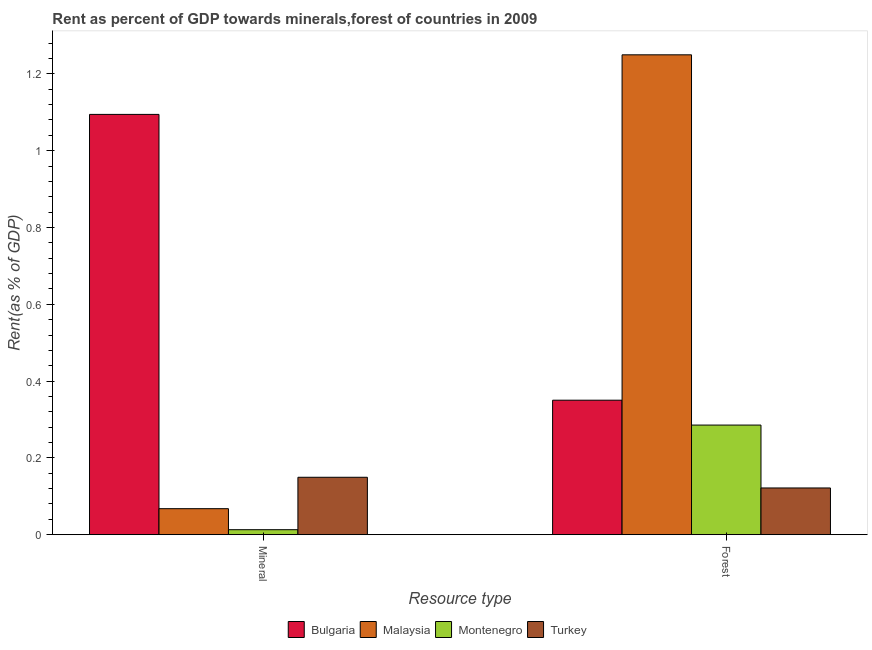How many different coloured bars are there?
Provide a succinct answer. 4. How many groups of bars are there?
Your answer should be very brief. 2. Are the number of bars per tick equal to the number of legend labels?
Your answer should be compact. Yes. Are the number of bars on each tick of the X-axis equal?
Offer a very short reply. Yes. How many bars are there on the 1st tick from the left?
Your response must be concise. 4. How many bars are there on the 2nd tick from the right?
Your answer should be compact. 4. What is the label of the 2nd group of bars from the left?
Ensure brevity in your answer.  Forest. What is the mineral rent in Montenegro?
Give a very brief answer. 0.01. Across all countries, what is the maximum forest rent?
Your answer should be very brief. 1.25. Across all countries, what is the minimum mineral rent?
Provide a succinct answer. 0.01. In which country was the mineral rent maximum?
Make the answer very short. Bulgaria. In which country was the mineral rent minimum?
Ensure brevity in your answer.  Montenegro. What is the total forest rent in the graph?
Keep it short and to the point. 2.01. What is the difference between the mineral rent in Bulgaria and that in Turkey?
Provide a short and direct response. 0.95. What is the difference between the mineral rent in Montenegro and the forest rent in Malaysia?
Provide a succinct answer. -1.24. What is the average forest rent per country?
Your response must be concise. 0.5. What is the difference between the forest rent and mineral rent in Bulgaria?
Make the answer very short. -0.74. In how many countries, is the mineral rent greater than 0.6400000000000001 %?
Keep it short and to the point. 1. What is the ratio of the mineral rent in Malaysia to that in Montenegro?
Provide a short and direct response. 5.21. Is the forest rent in Bulgaria less than that in Turkey?
Your answer should be very brief. No. In how many countries, is the mineral rent greater than the average mineral rent taken over all countries?
Provide a short and direct response. 1. What does the 4th bar from the left in Forest represents?
Your answer should be compact. Turkey. What does the 3rd bar from the right in Forest represents?
Your answer should be very brief. Malaysia. How many bars are there?
Provide a short and direct response. 8. Are all the bars in the graph horizontal?
Your response must be concise. No. How many countries are there in the graph?
Your answer should be compact. 4. What is the difference between two consecutive major ticks on the Y-axis?
Keep it short and to the point. 0.2. Does the graph contain grids?
Provide a short and direct response. No. How many legend labels are there?
Offer a terse response. 4. What is the title of the graph?
Offer a very short reply. Rent as percent of GDP towards minerals,forest of countries in 2009. What is the label or title of the X-axis?
Offer a terse response. Resource type. What is the label or title of the Y-axis?
Your answer should be very brief. Rent(as % of GDP). What is the Rent(as % of GDP) of Bulgaria in Mineral?
Your answer should be compact. 1.09. What is the Rent(as % of GDP) of Malaysia in Mineral?
Offer a terse response. 0.07. What is the Rent(as % of GDP) of Montenegro in Mineral?
Keep it short and to the point. 0.01. What is the Rent(as % of GDP) in Turkey in Mineral?
Ensure brevity in your answer.  0.15. What is the Rent(as % of GDP) of Bulgaria in Forest?
Make the answer very short. 0.35. What is the Rent(as % of GDP) in Malaysia in Forest?
Give a very brief answer. 1.25. What is the Rent(as % of GDP) of Montenegro in Forest?
Keep it short and to the point. 0.29. What is the Rent(as % of GDP) of Turkey in Forest?
Your answer should be very brief. 0.12. Across all Resource type, what is the maximum Rent(as % of GDP) of Bulgaria?
Provide a succinct answer. 1.09. Across all Resource type, what is the maximum Rent(as % of GDP) in Malaysia?
Ensure brevity in your answer.  1.25. Across all Resource type, what is the maximum Rent(as % of GDP) in Montenegro?
Your answer should be very brief. 0.29. Across all Resource type, what is the maximum Rent(as % of GDP) of Turkey?
Give a very brief answer. 0.15. Across all Resource type, what is the minimum Rent(as % of GDP) in Bulgaria?
Provide a succinct answer. 0.35. Across all Resource type, what is the minimum Rent(as % of GDP) of Malaysia?
Offer a very short reply. 0.07. Across all Resource type, what is the minimum Rent(as % of GDP) of Montenegro?
Your answer should be very brief. 0.01. Across all Resource type, what is the minimum Rent(as % of GDP) in Turkey?
Your answer should be compact. 0.12. What is the total Rent(as % of GDP) of Bulgaria in the graph?
Give a very brief answer. 1.44. What is the total Rent(as % of GDP) of Malaysia in the graph?
Your answer should be compact. 1.32. What is the total Rent(as % of GDP) of Montenegro in the graph?
Your answer should be very brief. 0.3. What is the total Rent(as % of GDP) in Turkey in the graph?
Ensure brevity in your answer.  0.27. What is the difference between the Rent(as % of GDP) in Bulgaria in Mineral and that in Forest?
Ensure brevity in your answer.  0.74. What is the difference between the Rent(as % of GDP) of Malaysia in Mineral and that in Forest?
Ensure brevity in your answer.  -1.18. What is the difference between the Rent(as % of GDP) of Montenegro in Mineral and that in Forest?
Provide a short and direct response. -0.27. What is the difference between the Rent(as % of GDP) of Turkey in Mineral and that in Forest?
Keep it short and to the point. 0.03. What is the difference between the Rent(as % of GDP) in Bulgaria in Mineral and the Rent(as % of GDP) in Malaysia in Forest?
Provide a succinct answer. -0.16. What is the difference between the Rent(as % of GDP) of Bulgaria in Mineral and the Rent(as % of GDP) of Montenegro in Forest?
Provide a short and direct response. 0.81. What is the difference between the Rent(as % of GDP) in Bulgaria in Mineral and the Rent(as % of GDP) in Turkey in Forest?
Give a very brief answer. 0.97. What is the difference between the Rent(as % of GDP) in Malaysia in Mineral and the Rent(as % of GDP) in Montenegro in Forest?
Ensure brevity in your answer.  -0.22. What is the difference between the Rent(as % of GDP) in Malaysia in Mineral and the Rent(as % of GDP) in Turkey in Forest?
Keep it short and to the point. -0.05. What is the difference between the Rent(as % of GDP) of Montenegro in Mineral and the Rent(as % of GDP) of Turkey in Forest?
Your response must be concise. -0.11. What is the average Rent(as % of GDP) in Bulgaria per Resource type?
Offer a very short reply. 0.72. What is the average Rent(as % of GDP) in Malaysia per Resource type?
Your response must be concise. 0.66. What is the average Rent(as % of GDP) of Montenegro per Resource type?
Your response must be concise. 0.15. What is the average Rent(as % of GDP) in Turkey per Resource type?
Ensure brevity in your answer.  0.14. What is the difference between the Rent(as % of GDP) in Bulgaria and Rent(as % of GDP) in Malaysia in Mineral?
Your answer should be very brief. 1.03. What is the difference between the Rent(as % of GDP) in Bulgaria and Rent(as % of GDP) in Montenegro in Mineral?
Keep it short and to the point. 1.08. What is the difference between the Rent(as % of GDP) in Bulgaria and Rent(as % of GDP) in Turkey in Mineral?
Make the answer very short. 0.94. What is the difference between the Rent(as % of GDP) of Malaysia and Rent(as % of GDP) of Montenegro in Mineral?
Provide a short and direct response. 0.05. What is the difference between the Rent(as % of GDP) in Malaysia and Rent(as % of GDP) in Turkey in Mineral?
Offer a very short reply. -0.08. What is the difference between the Rent(as % of GDP) in Montenegro and Rent(as % of GDP) in Turkey in Mineral?
Keep it short and to the point. -0.14. What is the difference between the Rent(as % of GDP) in Bulgaria and Rent(as % of GDP) in Malaysia in Forest?
Your response must be concise. -0.9. What is the difference between the Rent(as % of GDP) in Bulgaria and Rent(as % of GDP) in Montenegro in Forest?
Provide a succinct answer. 0.06. What is the difference between the Rent(as % of GDP) in Bulgaria and Rent(as % of GDP) in Turkey in Forest?
Your answer should be compact. 0.23. What is the difference between the Rent(as % of GDP) in Malaysia and Rent(as % of GDP) in Montenegro in Forest?
Your response must be concise. 0.96. What is the difference between the Rent(as % of GDP) of Malaysia and Rent(as % of GDP) of Turkey in Forest?
Your answer should be compact. 1.13. What is the difference between the Rent(as % of GDP) in Montenegro and Rent(as % of GDP) in Turkey in Forest?
Make the answer very short. 0.16. What is the ratio of the Rent(as % of GDP) of Bulgaria in Mineral to that in Forest?
Provide a succinct answer. 3.12. What is the ratio of the Rent(as % of GDP) of Malaysia in Mineral to that in Forest?
Provide a succinct answer. 0.05. What is the ratio of the Rent(as % of GDP) of Montenegro in Mineral to that in Forest?
Your answer should be compact. 0.05. What is the ratio of the Rent(as % of GDP) of Turkey in Mineral to that in Forest?
Keep it short and to the point. 1.23. What is the difference between the highest and the second highest Rent(as % of GDP) in Bulgaria?
Your response must be concise. 0.74. What is the difference between the highest and the second highest Rent(as % of GDP) of Malaysia?
Offer a very short reply. 1.18. What is the difference between the highest and the second highest Rent(as % of GDP) of Montenegro?
Provide a short and direct response. 0.27. What is the difference between the highest and the second highest Rent(as % of GDP) of Turkey?
Offer a very short reply. 0.03. What is the difference between the highest and the lowest Rent(as % of GDP) of Bulgaria?
Your response must be concise. 0.74. What is the difference between the highest and the lowest Rent(as % of GDP) of Malaysia?
Offer a terse response. 1.18. What is the difference between the highest and the lowest Rent(as % of GDP) in Montenegro?
Give a very brief answer. 0.27. What is the difference between the highest and the lowest Rent(as % of GDP) in Turkey?
Provide a succinct answer. 0.03. 